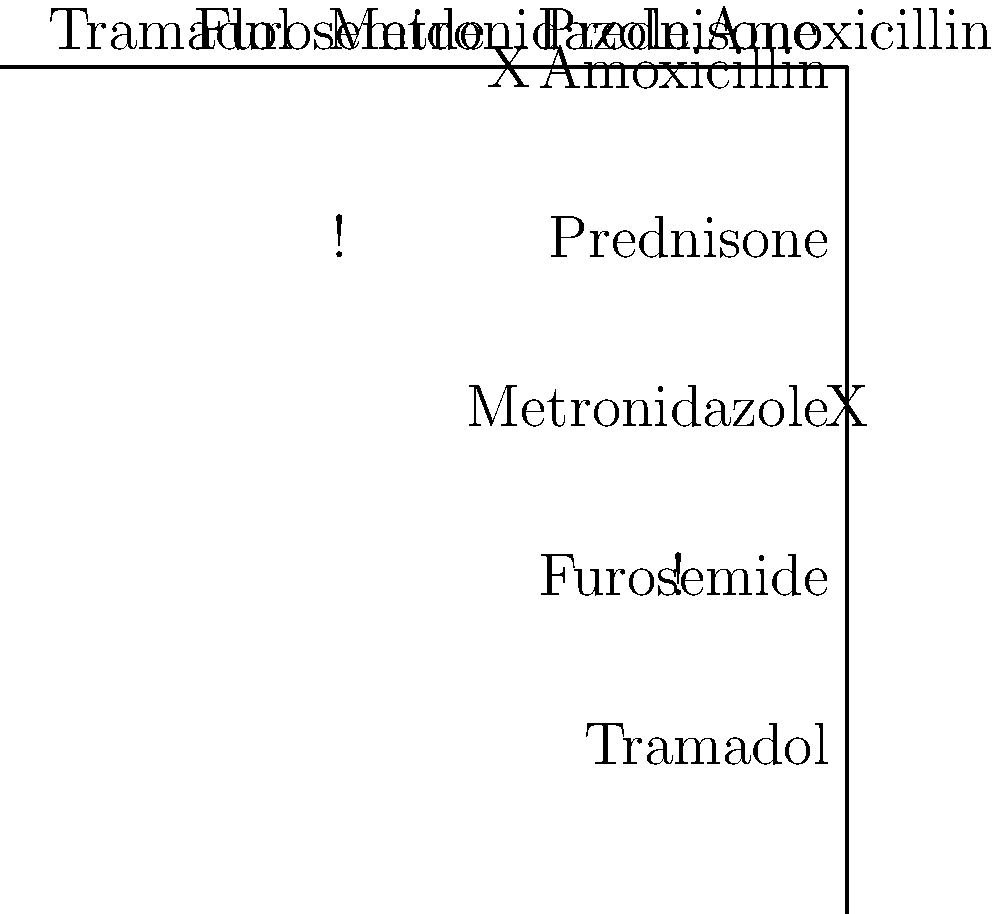Using the drug interaction matrix diagram provided, which two medications show a potential interaction that requires close monitoring (indicated by "!") when administered together? To identify the medications with a potential interaction requiring close monitoring, we need to follow these steps:

1. Examine the matrix diagram, focusing on the symbols used:
   - "X" indicates a contraindicated combination
   - "!" indicates a combination that requires close monitoring

2. Scan the matrix for the "!" symbol:
   - We find the "!" symbol at the intersection of Prednisone and Furosemide

3. Interpret the matrix:
   - The rows and columns are labeled with drug names
   - The intersection point indicates the interaction between two drugs

4. Identify the drugs:
   - Following the row for Prednisone, we find the "!" in the Furosemide column
   - Following the column for Furosemide, we find the "!" in the Prednisone row

5. Conclude:
   - The two medications showing a potential interaction requiring close monitoring are Prednisone and Furosemide

As a veterinary pharmacist specializing in compounding custom pet medications, it's crucial to be aware of this interaction when prescribing or compounding medications containing these active ingredients for pets.
Answer: Prednisone and Furosemide 